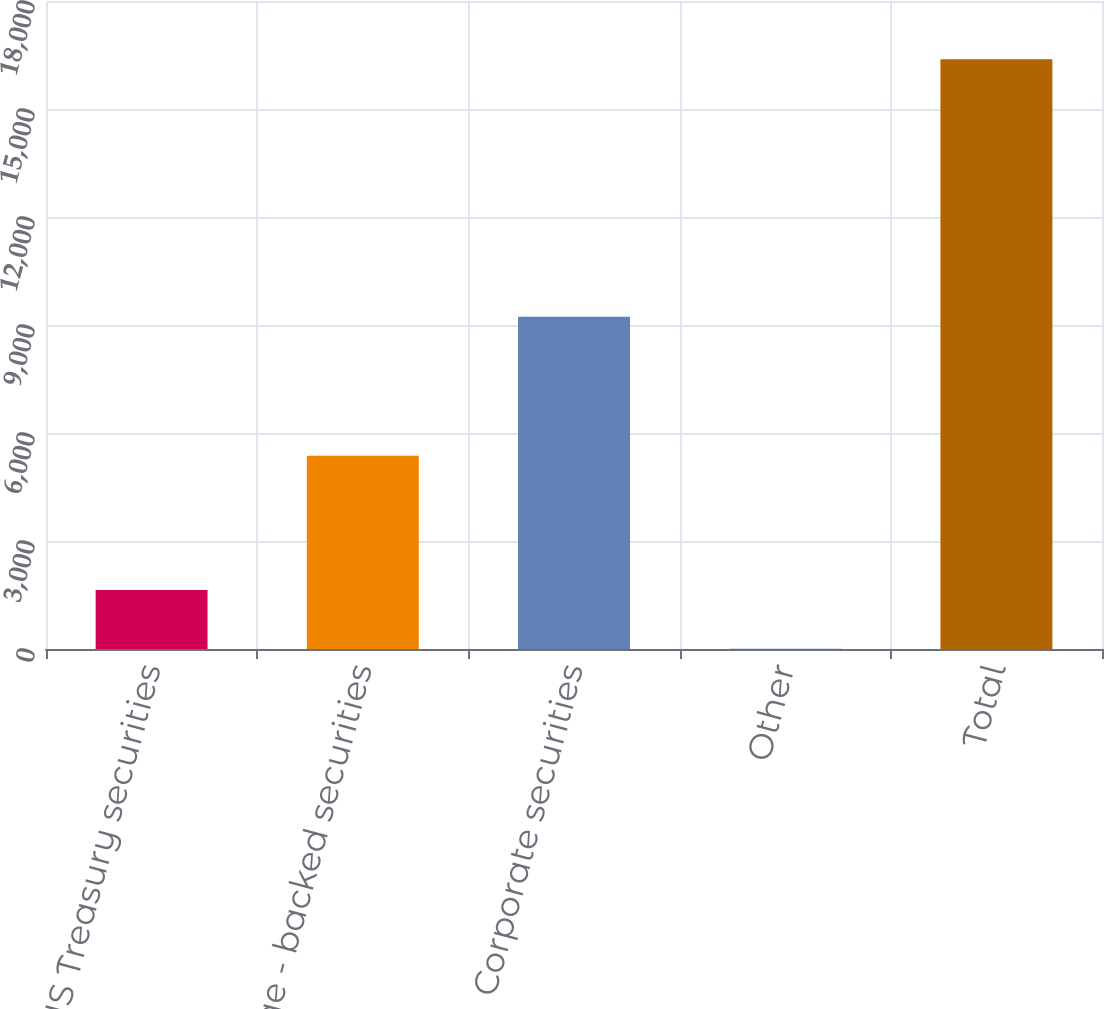<chart> <loc_0><loc_0><loc_500><loc_500><bar_chart><fcel>US Treasury securities<fcel>Mortgage - backed securities<fcel>Corporate securities<fcel>Other<fcel>Total<nl><fcel>1641.6<fcel>5365<fcel>9228<fcel>4<fcel>16380<nl></chart> 